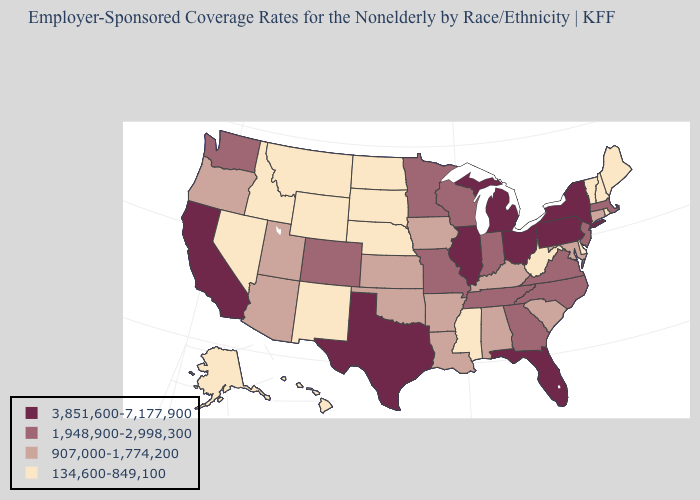Does the map have missing data?
Write a very short answer. No. Name the states that have a value in the range 907,000-1,774,200?
Concise answer only. Alabama, Arizona, Arkansas, Connecticut, Iowa, Kansas, Kentucky, Louisiana, Maryland, Oklahoma, Oregon, South Carolina, Utah. What is the value of West Virginia?
Be succinct. 134,600-849,100. Does Virginia have the highest value in the South?
Concise answer only. No. What is the value of North Carolina?
Keep it brief. 1,948,900-2,998,300. Which states hav the highest value in the MidWest?
Answer briefly. Illinois, Michigan, Ohio. Which states hav the highest value in the MidWest?
Keep it brief. Illinois, Michigan, Ohio. Does Kentucky have the lowest value in the USA?
Give a very brief answer. No. Name the states that have a value in the range 907,000-1,774,200?
Concise answer only. Alabama, Arizona, Arkansas, Connecticut, Iowa, Kansas, Kentucky, Louisiana, Maryland, Oklahoma, Oregon, South Carolina, Utah. What is the lowest value in the USA?
Quick response, please. 134,600-849,100. Name the states that have a value in the range 1,948,900-2,998,300?
Quick response, please. Colorado, Georgia, Indiana, Massachusetts, Minnesota, Missouri, New Jersey, North Carolina, Tennessee, Virginia, Washington, Wisconsin. Does Georgia have a higher value than New York?
Quick response, please. No. Which states have the lowest value in the USA?
Quick response, please. Alaska, Delaware, Hawaii, Idaho, Maine, Mississippi, Montana, Nebraska, Nevada, New Hampshire, New Mexico, North Dakota, Rhode Island, South Dakota, Vermont, West Virginia, Wyoming. Does New York have the highest value in the USA?
Keep it brief. Yes. 